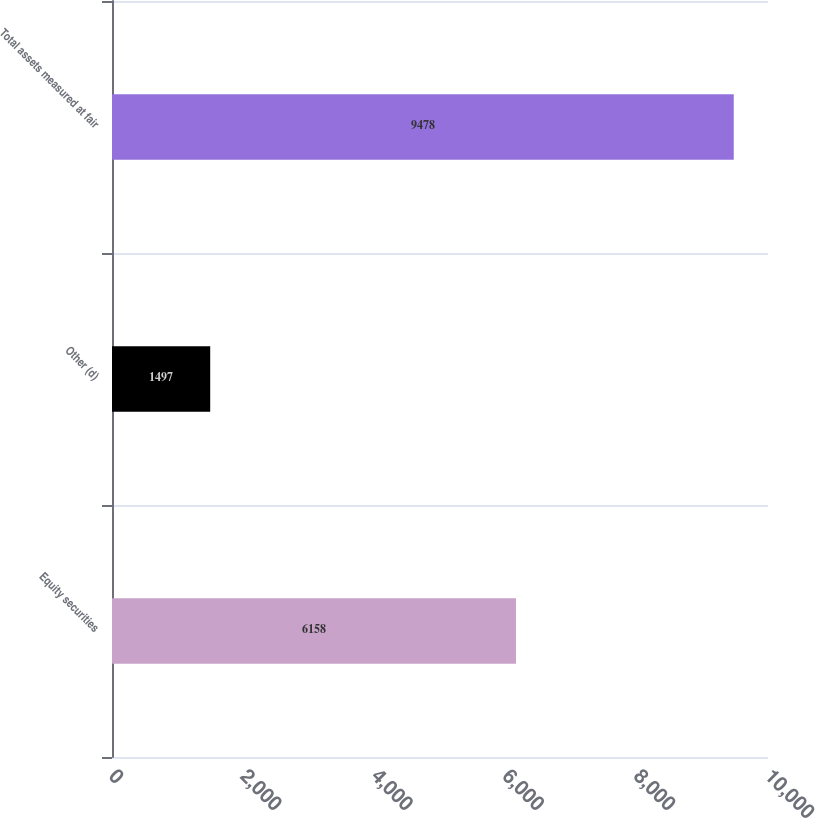<chart> <loc_0><loc_0><loc_500><loc_500><bar_chart><fcel>Equity securities<fcel>Other (d)<fcel>Total assets measured at fair<nl><fcel>6158<fcel>1497<fcel>9478<nl></chart> 